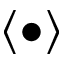<formula> <loc_0><loc_0><loc_500><loc_500>\langle \bullet \rangle</formula> 